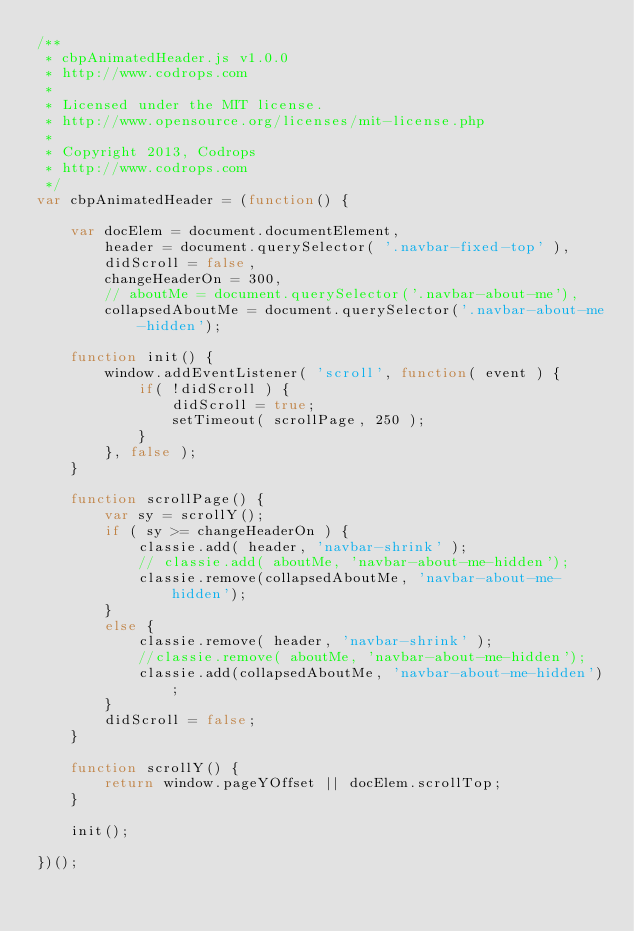<code> <loc_0><loc_0><loc_500><loc_500><_JavaScript_>/**
 * cbpAnimatedHeader.js v1.0.0
 * http://www.codrops.com
 *
 * Licensed under the MIT license.
 * http://www.opensource.org/licenses/mit-license.php
 * 
 * Copyright 2013, Codrops
 * http://www.codrops.com
 */
var cbpAnimatedHeader = (function() {

	var docElem = document.documentElement,
		header = document.querySelector( '.navbar-fixed-top' ),
		didScroll = false,
		changeHeaderOn = 300,
		// aboutMe = document.querySelector('.navbar-about-me'),
		collapsedAboutMe = document.querySelector('.navbar-about-me-hidden');

	function init() {
		window.addEventListener( 'scroll', function( event ) {
			if( !didScroll ) {
				didScroll = true;
				setTimeout( scrollPage, 250 );
			}
		}, false );
	}

	function scrollPage() {
		var sy = scrollY();
		if ( sy >= changeHeaderOn ) {
			classie.add( header, 'navbar-shrink' );
			// classie.add( aboutMe, 'navbar-about-me-hidden');
			classie.remove(collapsedAboutMe, 'navbar-about-me-hidden');
		}
		else {
			classie.remove( header, 'navbar-shrink' );
			//classie.remove( aboutMe, 'navbar-about-me-hidden');
			classie.add(collapsedAboutMe, 'navbar-about-me-hidden');
		}
		didScroll = false;
	}

	function scrollY() {
		return window.pageYOffset || docElem.scrollTop;
	}

	init();

})();</code> 